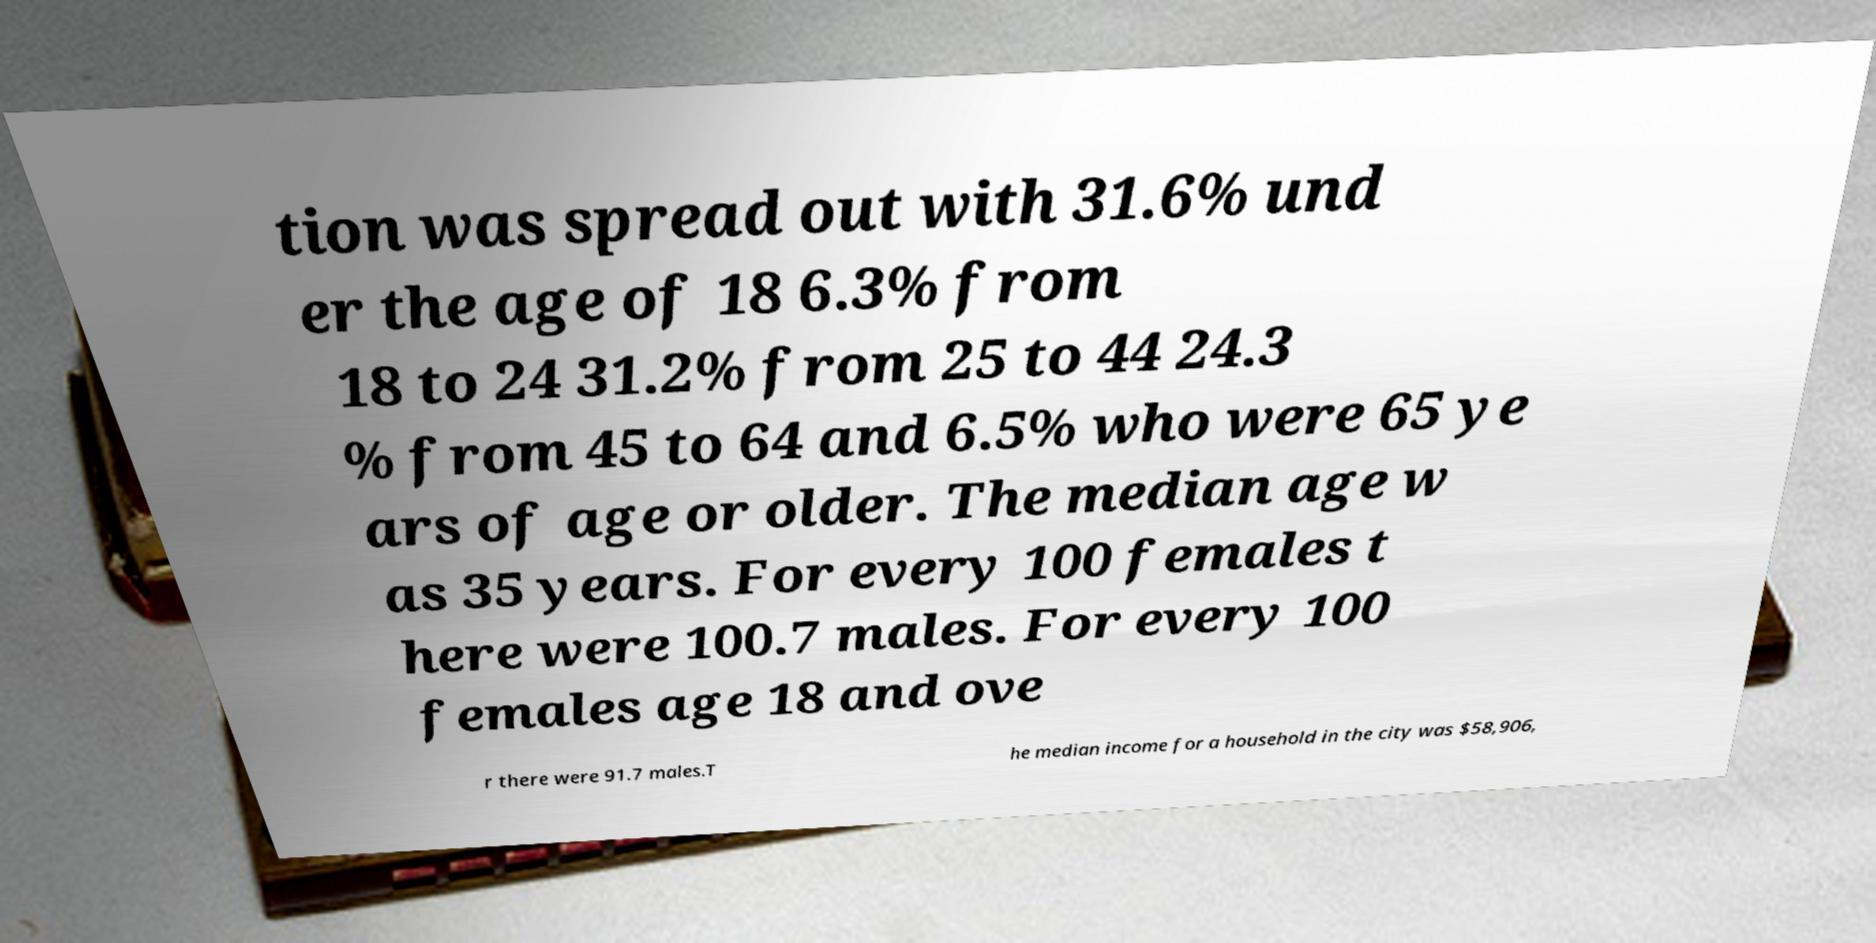Could you extract and type out the text from this image? tion was spread out with 31.6% und er the age of 18 6.3% from 18 to 24 31.2% from 25 to 44 24.3 % from 45 to 64 and 6.5% who were 65 ye ars of age or older. The median age w as 35 years. For every 100 females t here were 100.7 males. For every 100 females age 18 and ove r there were 91.7 males.T he median income for a household in the city was $58,906, 